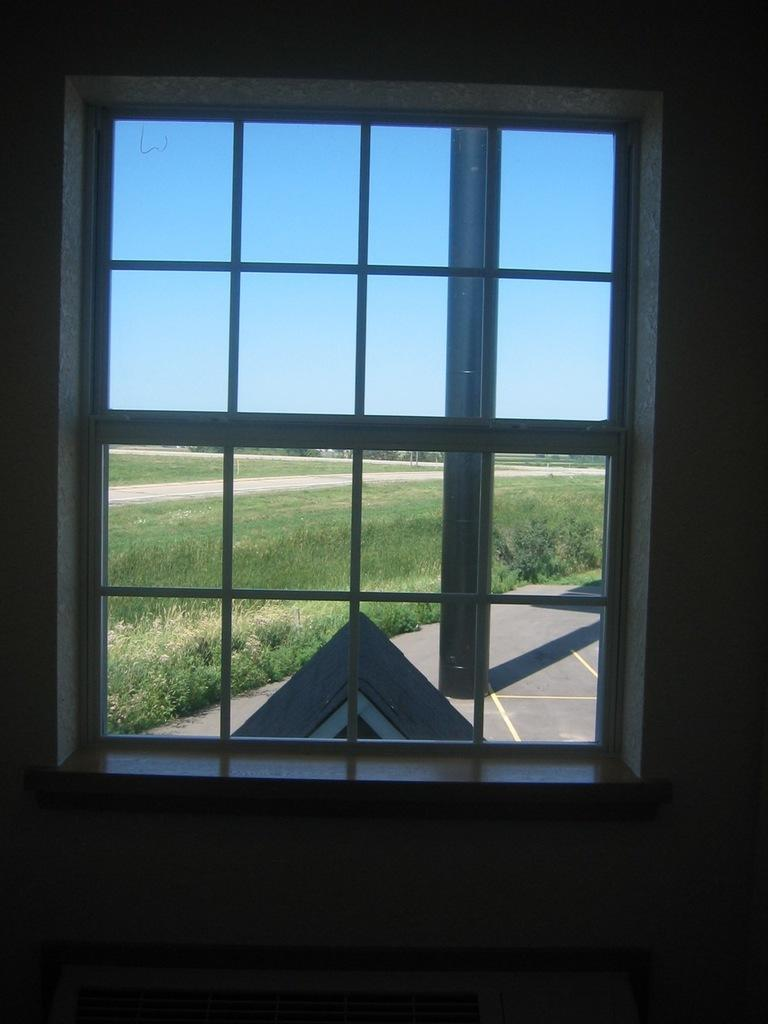What can be seen on the interior side of the image? There is a window and a wall visible in the image. What is visible outside the window in the image? Trees, bushes, grass, and roads are visible outside the window in the image. How many bananas are being smashed on the wall in the image? There are no bananas or any smashing activity present in the image. 